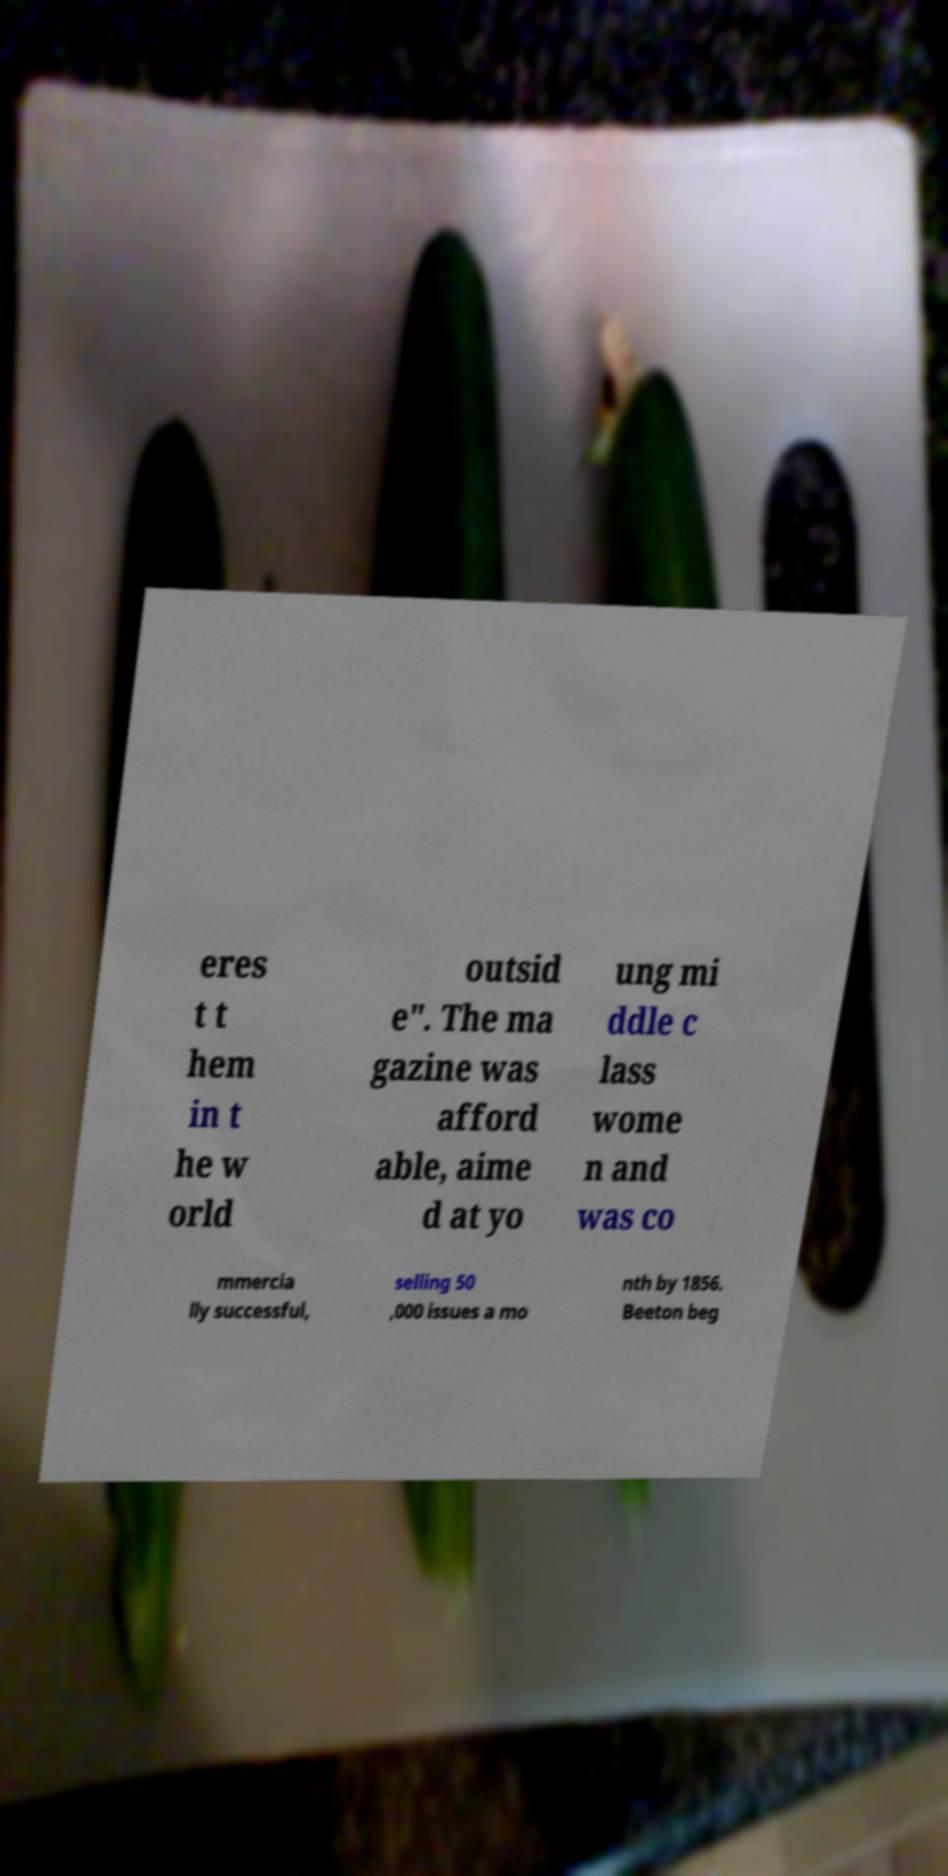For documentation purposes, I need the text within this image transcribed. Could you provide that? eres t t hem in t he w orld outsid e". The ma gazine was afford able, aime d at yo ung mi ddle c lass wome n and was co mmercia lly successful, selling 50 ,000 issues a mo nth by 1856. Beeton beg 